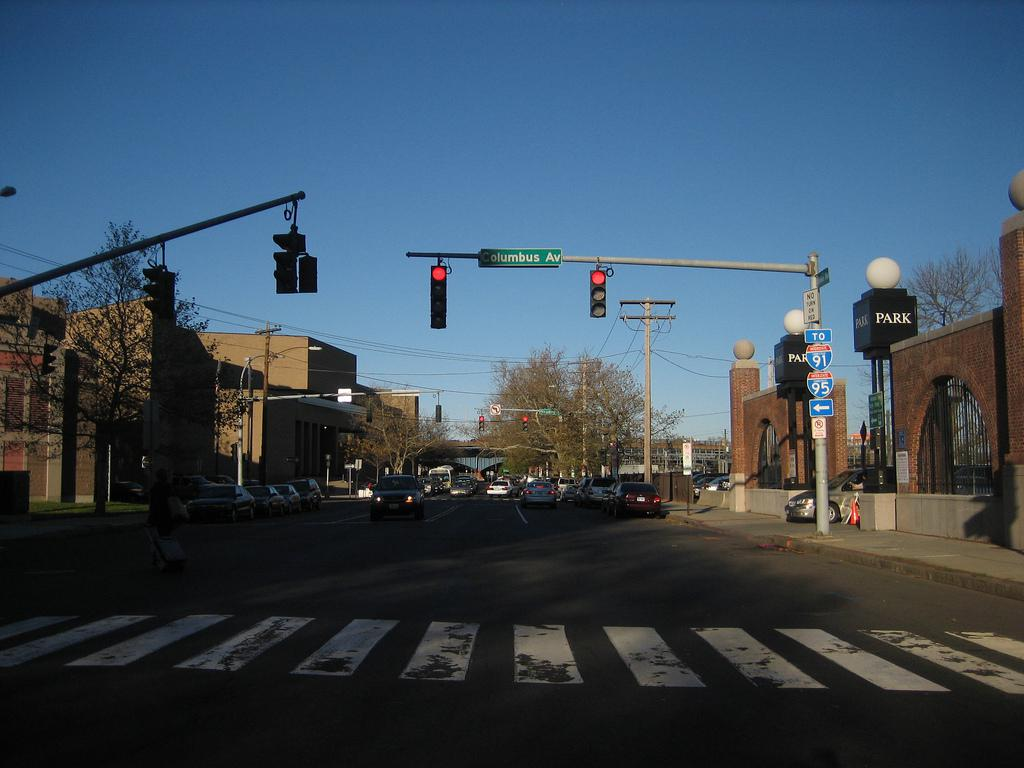Question: why are the cars stopped?
Choices:
A. There's a traffic jam.
B. Someone is crossing the road.
C. It's a red light.
D. There's a wreck up ahead.
Answer with the letter. Answer: C Question: how are the cars being driven?
Choices:
A. By people.
B. Recklessly.
C. Slowly.
D. By cats.
Answer with the letter. Answer: A Question: what does the street sign say?
Choices:
A. Main St.
B. Columbus av.
C. Nelms Ave.
D. Buckner Ln.
Answer with the letter. Answer: B Question: what color is the street light?
Choices:
A. Yellow.
B. Green.
C. Orange.
D. Red.
Answer with the letter. Answer: D Question: what does the black sign say in white?
Choices:
A. Exit.
B. Park.
C. Free.
D. Library.
Answer with the letter. Answer: B Question: where was the photo taken?
Choices:
A. At the zoo.
B. At school.
C. At a crosswalk.
D. At a photo booth.
Answer with the letter. Answer: C Question: where was the photo taken?
Choices:
A. Train station.
B. On a street.
C. A hockey game.
D. Paris.
Answer with the letter. Answer: B Question: what color are the traffic lights?
Choices:
A. Green.
B. Yellow.
C. Red.
D. Amber.
Answer with the letter. Answer: C Question: where are there white stripes?
Choices:
A. In the street.
B. On the building.
C. On the house.
D. In the crosswalk.
Answer with the letter. Answer: D Question: what street does this scene show?
Choices:
A. 32nd street.
B. 5th Avenue.
C. Columbus avenue.
D. Lennox Ave.
Answer with the letter. Answer: C Question: what are there signs for?
Choices:
A. Streets Main and Second.
B. Avenues Broadway and Lexington.
C. Roads Creek and Lake.
D. Routes 91 and 95.
Answer with the letter. Answer: D Question: what lines the street?
Choices:
A. Cars.
B. Homes.
C. Trees.
D. Buildings.
Answer with the letter. Answer: D 